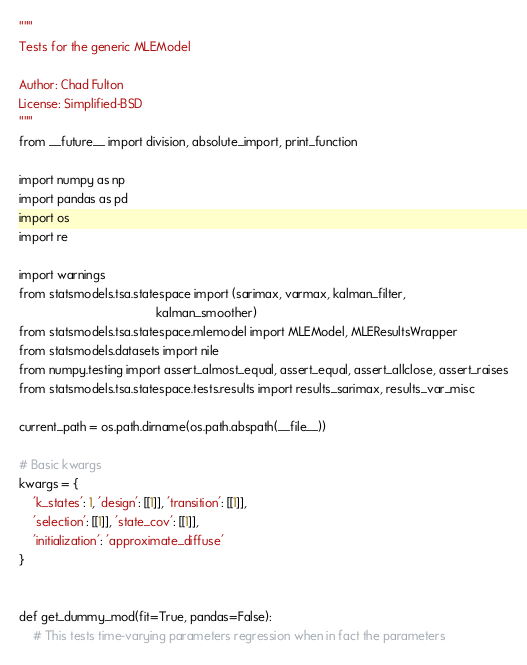Convert code to text. <code><loc_0><loc_0><loc_500><loc_500><_Python_>"""
Tests for the generic MLEModel

Author: Chad Fulton
License: Simplified-BSD
"""
from __future__ import division, absolute_import, print_function

import numpy as np
import pandas as pd
import os
import re

import warnings
from statsmodels.tsa.statespace import (sarimax, varmax, kalman_filter,
                                        kalman_smoother)
from statsmodels.tsa.statespace.mlemodel import MLEModel, MLEResultsWrapper
from statsmodels.datasets import nile
from numpy.testing import assert_almost_equal, assert_equal, assert_allclose, assert_raises
from statsmodels.tsa.statespace.tests.results import results_sarimax, results_var_misc

current_path = os.path.dirname(os.path.abspath(__file__))

# Basic kwargs
kwargs = {
    'k_states': 1, 'design': [[1]], 'transition': [[1]],
    'selection': [[1]], 'state_cov': [[1]],
    'initialization': 'approximate_diffuse'
}


def get_dummy_mod(fit=True, pandas=False):
    # This tests time-varying parameters regression when in fact the parameters</code> 